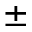<formula> <loc_0><loc_0><loc_500><loc_500>\pm</formula> 